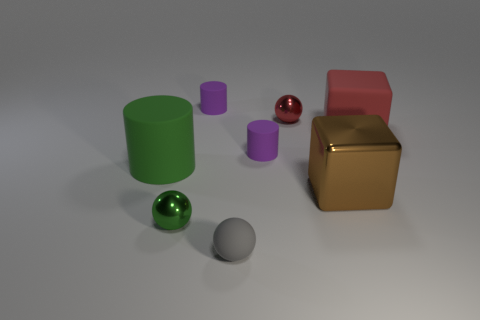If you had to guess, what purpose do you think this arrangement of objects serves? Given the arrangement, it seems like this might be a setup for a visual or artistic project. It could serve as an opportunity to study the interplay of light and shadow on objects of different shapes, materials, and colors, or it could be a preliminary composition for a graphic design, 3D modeling, or educational purpose, highlighting various geometric forms and textures. 